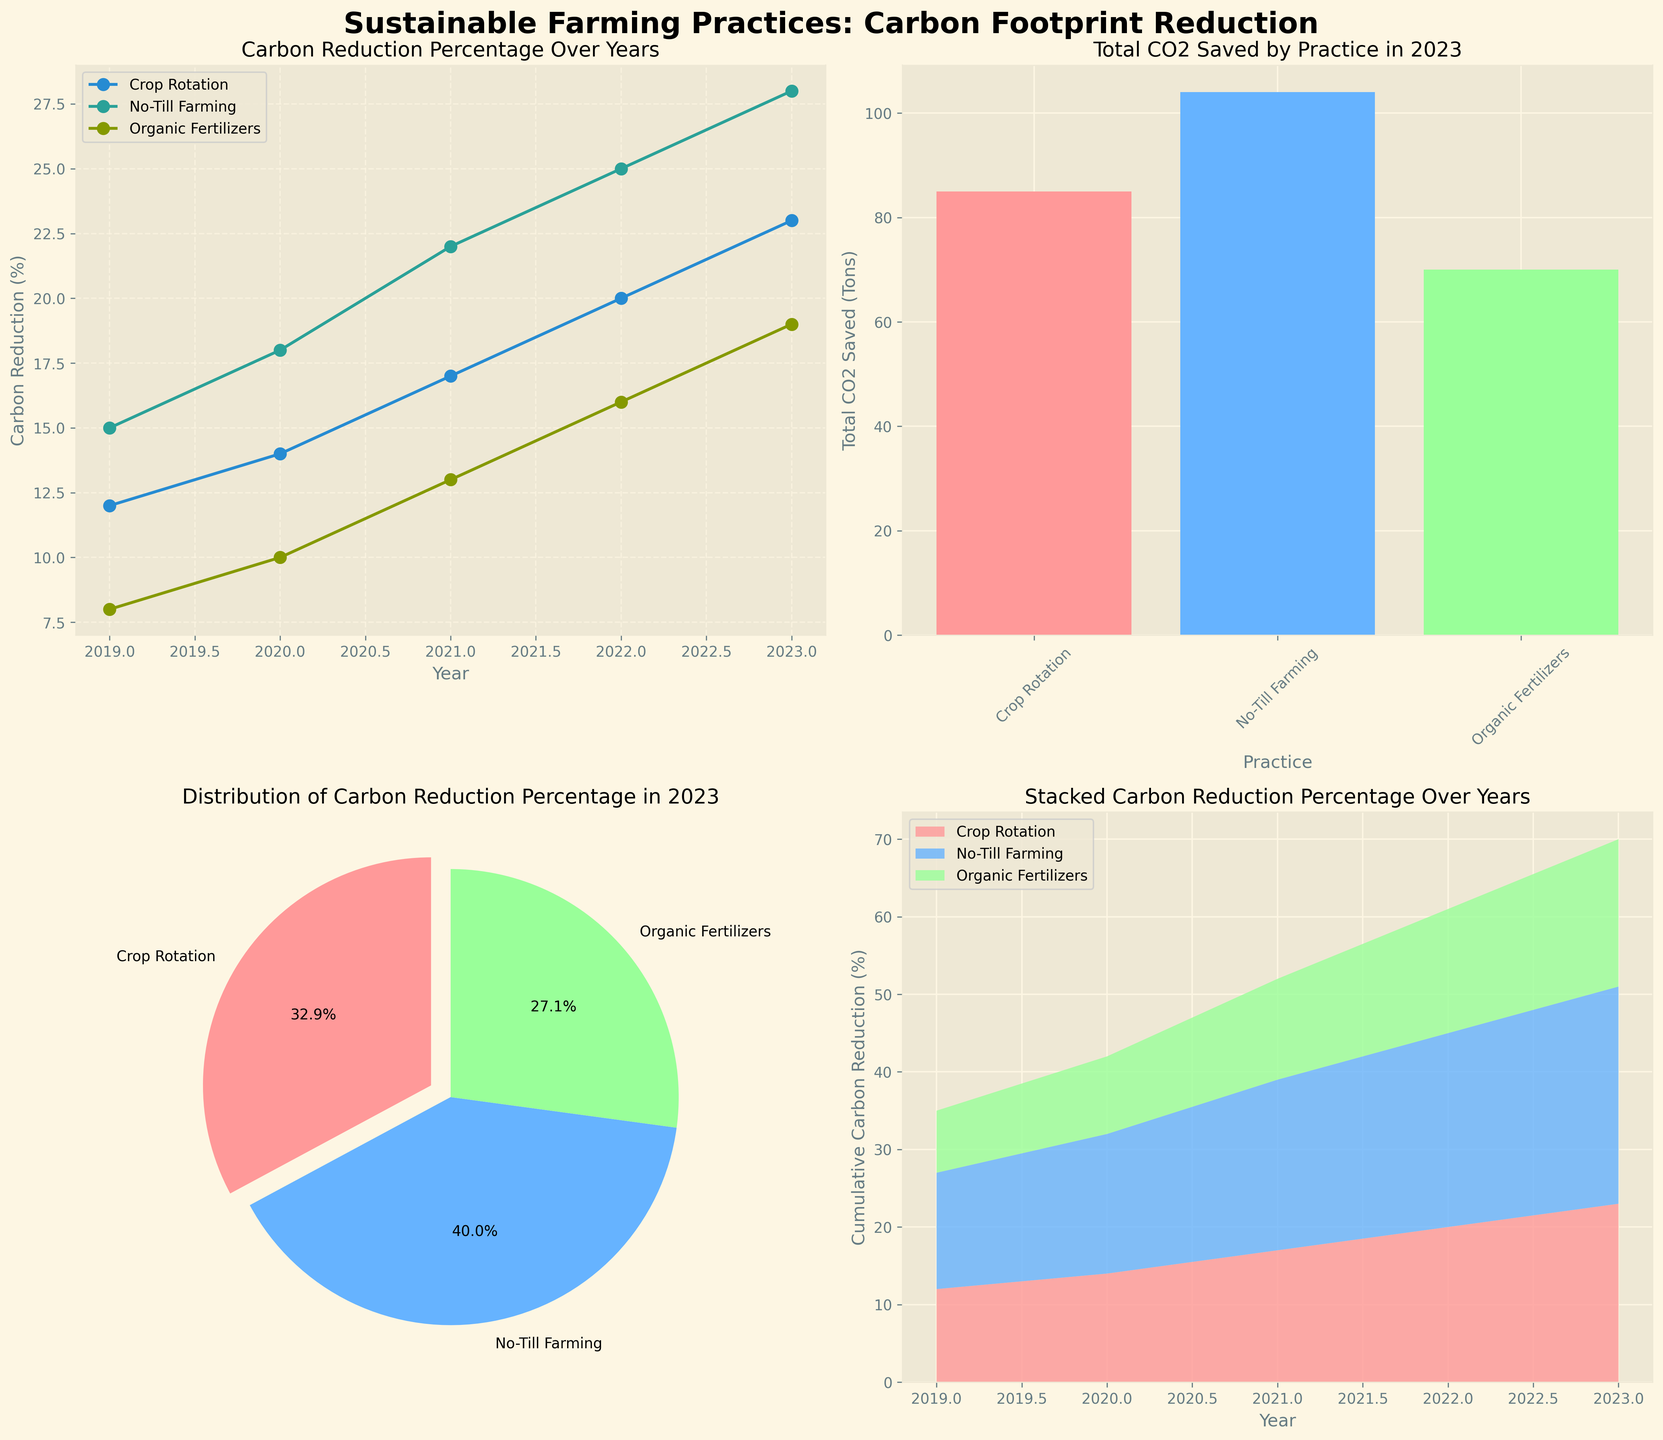What are the titles of the subplots in the figure? The titles can be found directly on each subplot of the figure. They are "Carbon Reduction Percentage Over Years," "Total CO2 Saved by Practice in 2023," "Distribution of Carbon Reduction Percentage in 2023," and "Stacked Carbon Reduction Percentage Over Years."
Answer: "Carbon Reduction Percentage Over Years", "Total CO2 Saved by Practice in 2023", "Distribution of Carbon Reduction Percentage in 2023", "Stacked Carbon Reduction Percentage Over Years" Which practice achieved the highest carbon reduction percentage in 2021? By looking at the "Carbon Reduction Percentage Over Years" line plot for 2021, we can see that "No-Till Farming" has the highest value.
Answer: No-Till Farming How much total CO2 was saved by all practices combined in 2023? Refer to the bar plot "Total CO2 Saved by Practice in 2023" and sum up the CO2 saved by each practice: 85 (Crop Rotation) + 104 (No-Till Farming) + 70 (Organic Fertilizers). The total is 259 tons.
Answer: 259 tons What is the percentage contribution of Organic Fertilizers to the total carbon reduction in 2023? Looking at the "Distribution of Carbon Reduction Percentage in 2023" pie chart, the slice labeled "Organic Fertilizers" has a percentage value of 19%.
Answer: 19% Between 2019 and 2023, which practice showed the most significant increase in Carbon Reduction Percentage? By comparing the "Carbon Reduction Percentage Over Years" for all practices, the increase for each practice can be calculated. The increases are 11% for Crop Rotation (23%-12%), 13% for No-Till Farming (28%-15%), and 11% for Organic Fertilizers (19%-8%). No-Till Farming shows the most significant increase.
Answer: No-Till Farming Which year saw the highest cumulative carbon reduction percentage across all practices? By looking at the "Stacked Carbon Reduction Percentage Over Years" for each year and summing up the percentages for each year, we can identify the year with the highest cumulative value. The highest cumulative value is in 2023.
Answer: 2023 What are the different colors used to represent practices in the pie chart? Refer to the "Distribution of Carbon Reduction Percentage in 2023" pie chart, where the colors for each labeled segment are light pink (Crop Rotation), light blue (No-Till Farming), and light green (Organic Fertilizers).
Answer: Light pink, light blue, light green 